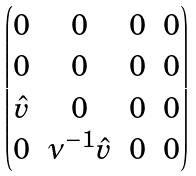Convert formula to latex. <formula><loc_0><loc_0><loc_500><loc_500>\begin{pmatrix} 0 & 0 & 0 & 0 \\ 0 & 0 & 0 & 0 \\ \hat { v } & 0 & 0 & 0 \\ 0 & \nu ^ { - 1 } \hat { v } & 0 & 0 \\ \end{pmatrix}</formula> 